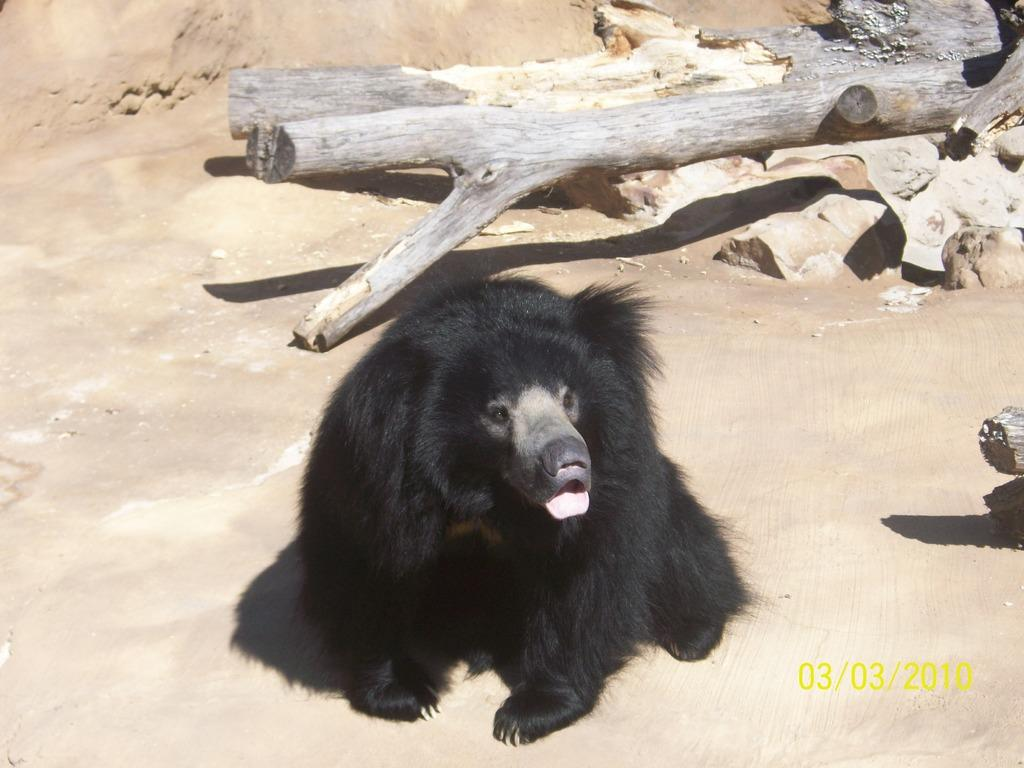What type of animal can be seen on the ground in the image? There is an animal on the ground in the image, but the specific type of animal is not mentioned in the facts. What can be seen in the background of the image? There are wooden logs and stones in the background of the image. What type of nut is the animal holding in the image? There is no nut present in the image, and the animal is not shown holding anything. 